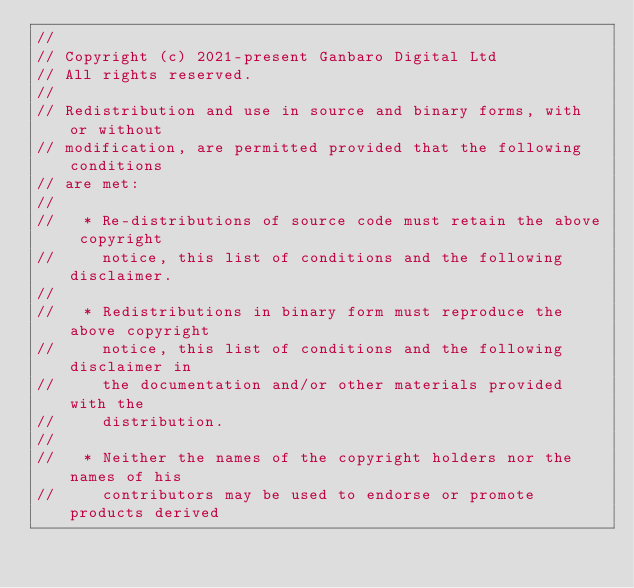<code> <loc_0><loc_0><loc_500><loc_500><_TypeScript_>//
// Copyright (c) 2021-present Ganbaro Digital Ltd
// All rights reserved.
//
// Redistribution and use in source and binary forms, with or without
// modification, are permitted provided that the following conditions
// are met:
//
//   * Re-distributions of source code must retain the above copyright
//     notice, this list of conditions and the following disclaimer.
//
//   * Redistributions in binary form must reproduce the above copyright
//     notice, this list of conditions and the following disclaimer in
//     the documentation and/or other materials provided with the
//     distribution.
//
//   * Neither the names of the copyright holders nor the names of his
//     contributors may be used to endorse or promote products derived</code> 